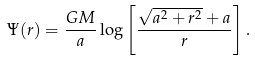Convert formula to latex. <formula><loc_0><loc_0><loc_500><loc_500>\Psi ( r ) = \frac { G M } { a } \log \left [ \frac { \sqrt { a ^ { 2 } + r ^ { 2 } } + a } { r } \right ] .</formula> 